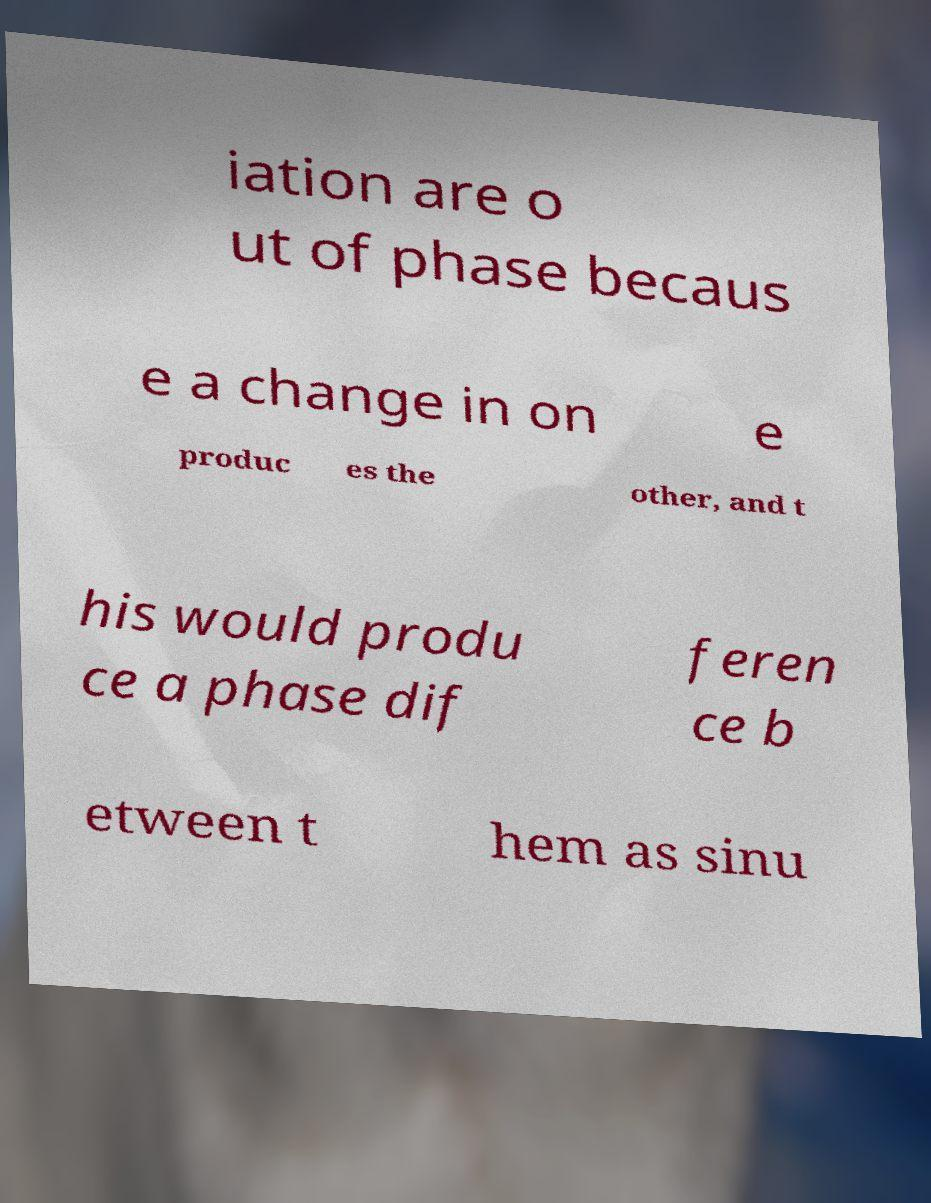Could you extract and type out the text from this image? iation are o ut of phase becaus e a change in on e produc es the other, and t his would produ ce a phase dif feren ce b etween t hem as sinu 